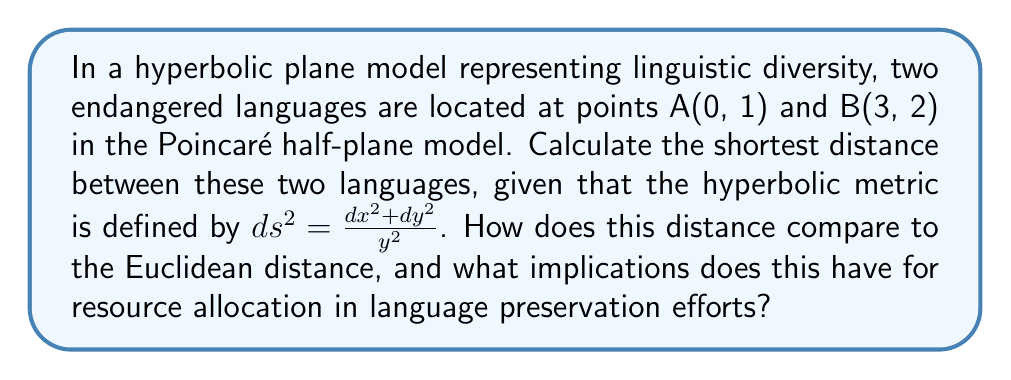Solve this math problem. To solve this problem, we'll follow these steps:

1) In the Poincaré half-plane model, the shortest path between two points is a semicircle orthogonal to the x-axis. We need to find this semicircle and calculate its hyperbolic length.

2) The general equation of a semicircle orthogonal to the x-axis and passing through points (x₁, y₁) and (x₂, y₂) is:

   $$(x - a)^2 + y^2 = r^2$$

   where (a, 0) is the center of the semicircle on the x-axis and r is its radius.

3) Substituting our points A(0, 1) and B(3, 2):

   $$(0 - a)^2 + 1^2 = r^2$$
   $$(3 - a)^2 + 2^2 = r^2$$

4) Subtracting these equations:

   $(3 - a)^2 - (-a)^2 = 0$
   $9 - 6a + a^2 - a^2 = 0$
   $9 - 6a = 0$
   $a = \frac{3}{2}$

5) Substituting back to find r:

   $(\frac{3}{2})^2 + 1^2 = r^2$
   $r^2 = \frac{13}{4}$
   $r = \frac{\sqrt{13}}{2}$

6) The hyperbolic distance is given by the integral:

   $$d = \int_{0}^{3} \frac{\sqrt{dx^2 + dy^2}}{y} = \int_{0}^{3} \frac{\sqrt{1 + (\frac{dy}{dx})^2}}{y} dx$$

7) On our semicircle, $y = \sqrt{r^2 - (x - a)^2}$. Differentiating:

   $$\frac{dy}{dx} = -\frac{x - a}{\sqrt{r^2 - (x - a)^2}}$$

8) Substituting into the integral:

   $$d = \int_{0}^{3} \frac{\sqrt{1 + (\frac{x - \frac{3}{2}}{\sqrt{\frac{13}{4} - (x - \frac{3}{2})^2}})^2}}{\sqrt{\frac{13}{4} - (x - \frac{3}{2})^2}} dx$$

9) This integral simplifies to:

   $$d = 2 \arcosh(\frac{3}{2}) \approx 1.9248$$

10) The Euclidean distance is:

    $$\sqrt{(3-0)^2 + (2-1)^2} = \sqrt{10} \approx 3.1623$$

11) The hyperbolic distance is shorter than the Euclidean distance, implying that the linguistic diversity space is "curved" and languages may be more closely related than they appear in a flat model. This suggests that resources for language preservation might be more efficiently allocated by considering this hyperbolic relationship, potentially allowing for more languages to be preserved with the same resources.
Answer: Hyperbolic distance: $2 \arcosh(\frac{3}{2}) \approx 1.9248$. Shorter than Euclidean distance, implying closer linguistic relationships and more efficient resource allocation for preservation. 